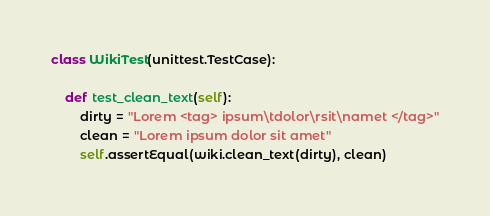Convert code to text. <code><loc_0><loc_0><loc_500><loc_500><_Python_>
class WikiTest(unittest.TestCase):

    def test_clean_text(self):
        dirty = "Lorem <tag> ipsum\tdolor\rsit\namet </tag>"
        clean = "Lorem ipsum dolor sit amet"
        self.assertEqual(wiki.clean_text(dirty), clean)
</code> 